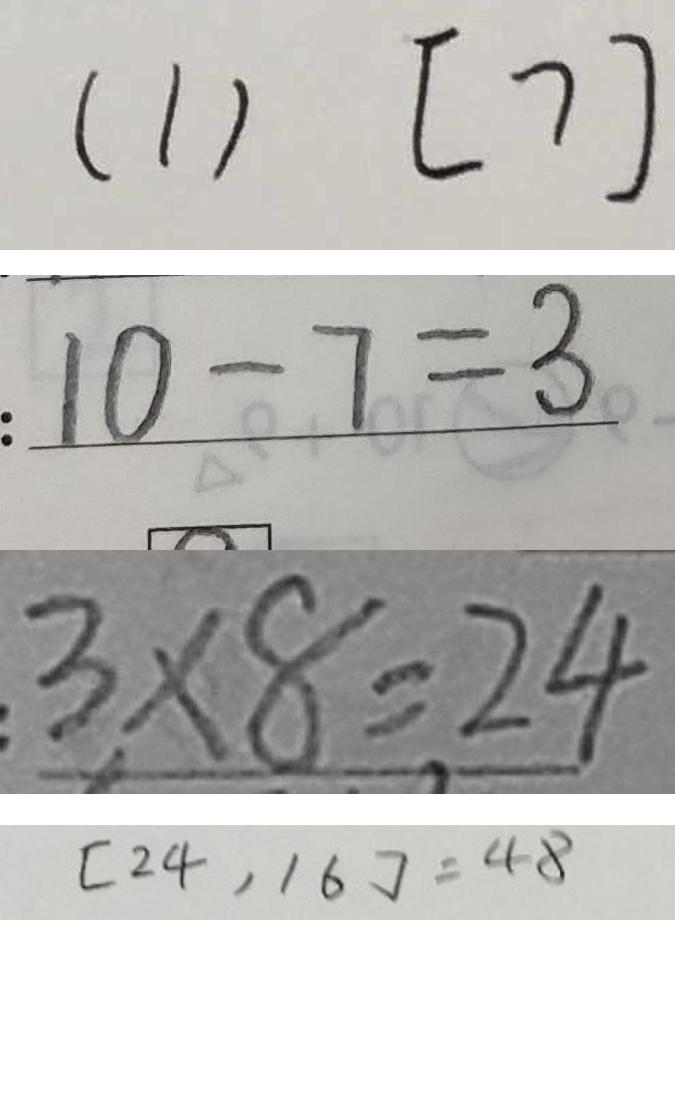<formula> <loc_0><loc_0><loc_500><loc_500>( 1 ) [ 7 ] 
 : 1 0 - 7 = 3 
 3 \times 8 = 2 4 
 [ 2 4 , 1 6 ] = 4 8</formula> 